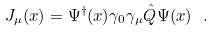Convert formula to latex. <formula><loc_0><loc_0><loc_500><loc_500>J _ { \mu } ( x ) = \Psi ^ { \dagger } ( x ) \gamma _ { 0 } \gamma _ { \mu } \hat { Q } \Psi ( x ) \ .</formula> 